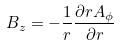<formula> <loc_0><loc_0><loc_500><loc_500>B _ { z } = - \frac { 1 } { r } \frac { \partial r A _ { \phi } } { \partial r }</formula> 